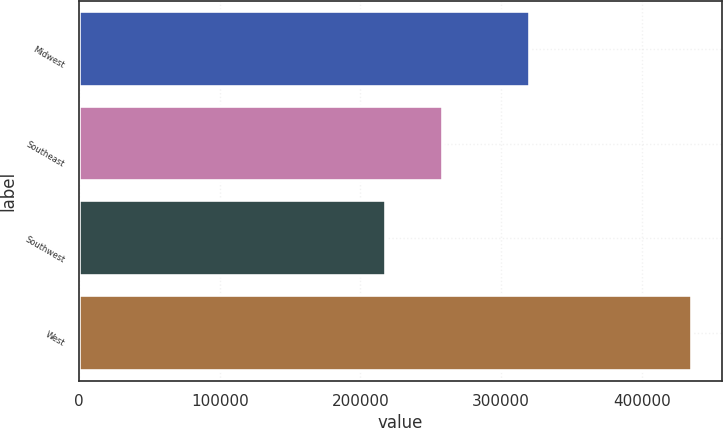Convert chart. <chart><loc_0><loc_0><loc_500><loc_500><bar_chart><fcel>Midwest<fcel>Southeast<fcel>Southwest<fcel>West<nl><fcel>320200<fcel>258400<fcel>218400<fcel>435400<nl></chart> 